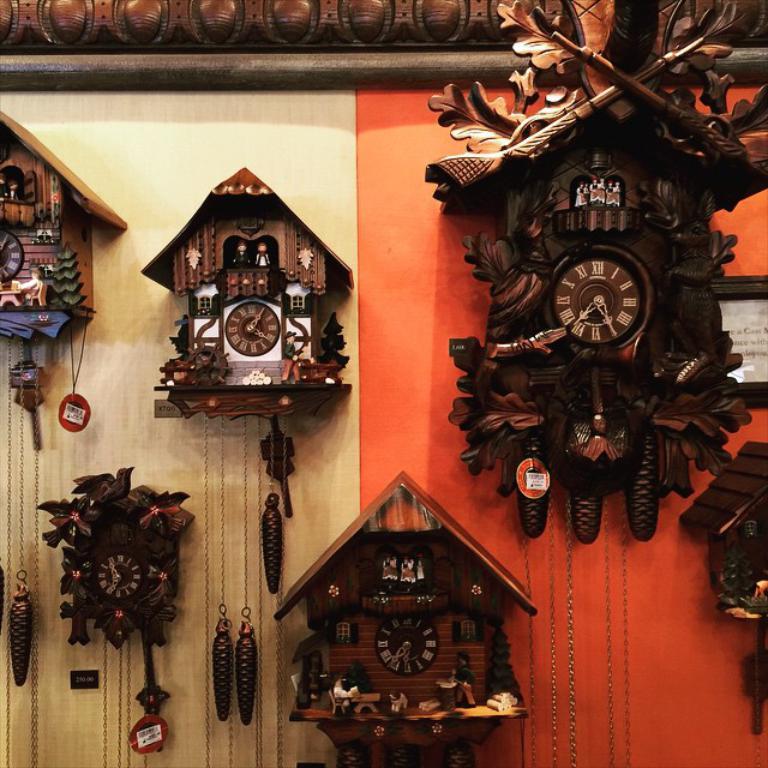What time does the clock with the 2 little people have on it?
Provide a succinct answer. 4:05. What time is on the clock in the top right?
Give a very brief answer. 7:25. 